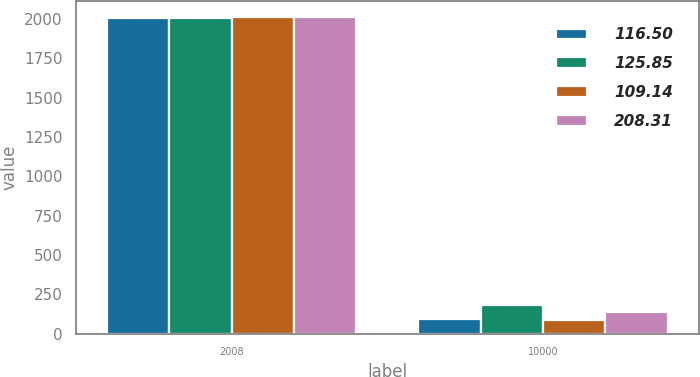<chart> <loc_0><loc_0><loc_500><loc_500><stacked_bar_chart><ecel><fcel>2008<fcel>10000<nl><fcel>116.5<fcel>2009<fcel>95.48<nl><fcel>125.85<fcel>2010<fcel>183.5<nl><fcel>109.14<fcel>2011<fcel>90.02<nl><fcel>208.31<fcel>2012<fcel>136.97<nl></chart> 